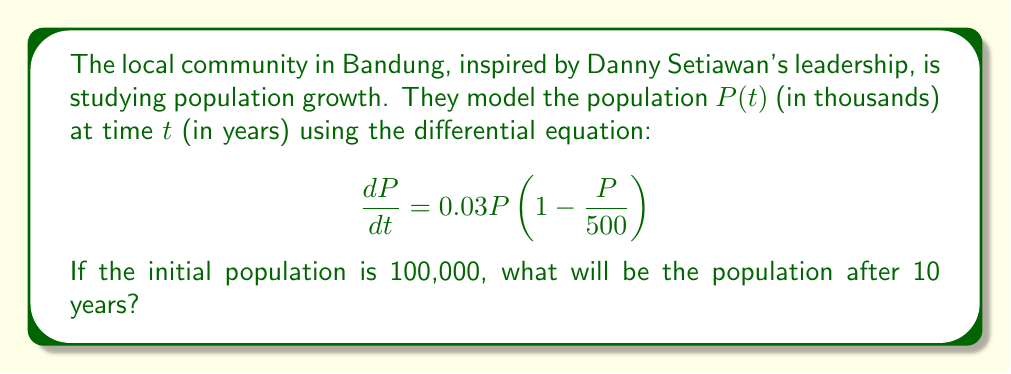Could you help me with this problem? To solve this problem, we'll follow these steps:

1) First, we recognize this as a logistic growth model with carrying capacity $K = 500$ thousand and growth rate $r = 0.03$.

2) The general solution for the logistic growth model is:

   $$P(t) = \frac{K}{1 + Ce^{-rt}}$$

   where $C$ is a constant we need to determine using the initial condition.

3) We're given that $P(0) = 100$ thousand. Let's substitute this into our general solution:

   $$100 = \frac{500}{1 + C}$$

4) Solving for $C$:

   $$1 + C = \frac{500}{100} = 5$$
   $$C = 4$$

5) Now our specific solution is:

   $$P(t) = \frac{500}{1 + 4e^{-0.03t}}$$

6) To find the population after 10 years, we substitute $t = 10$:

   $$P(10) = \frac{500}{1 + 4e^{-0.03(10)}}$$

7) Evaluating this:

   $$P(10) = \frac{500}{1 + 4e^{-0.3}} \approx 161.37$$

8) Therefore, after 10 years, the population will be approximately 161,370 people.
Answer: The population after 10 years will be approximately 161,370 people. 